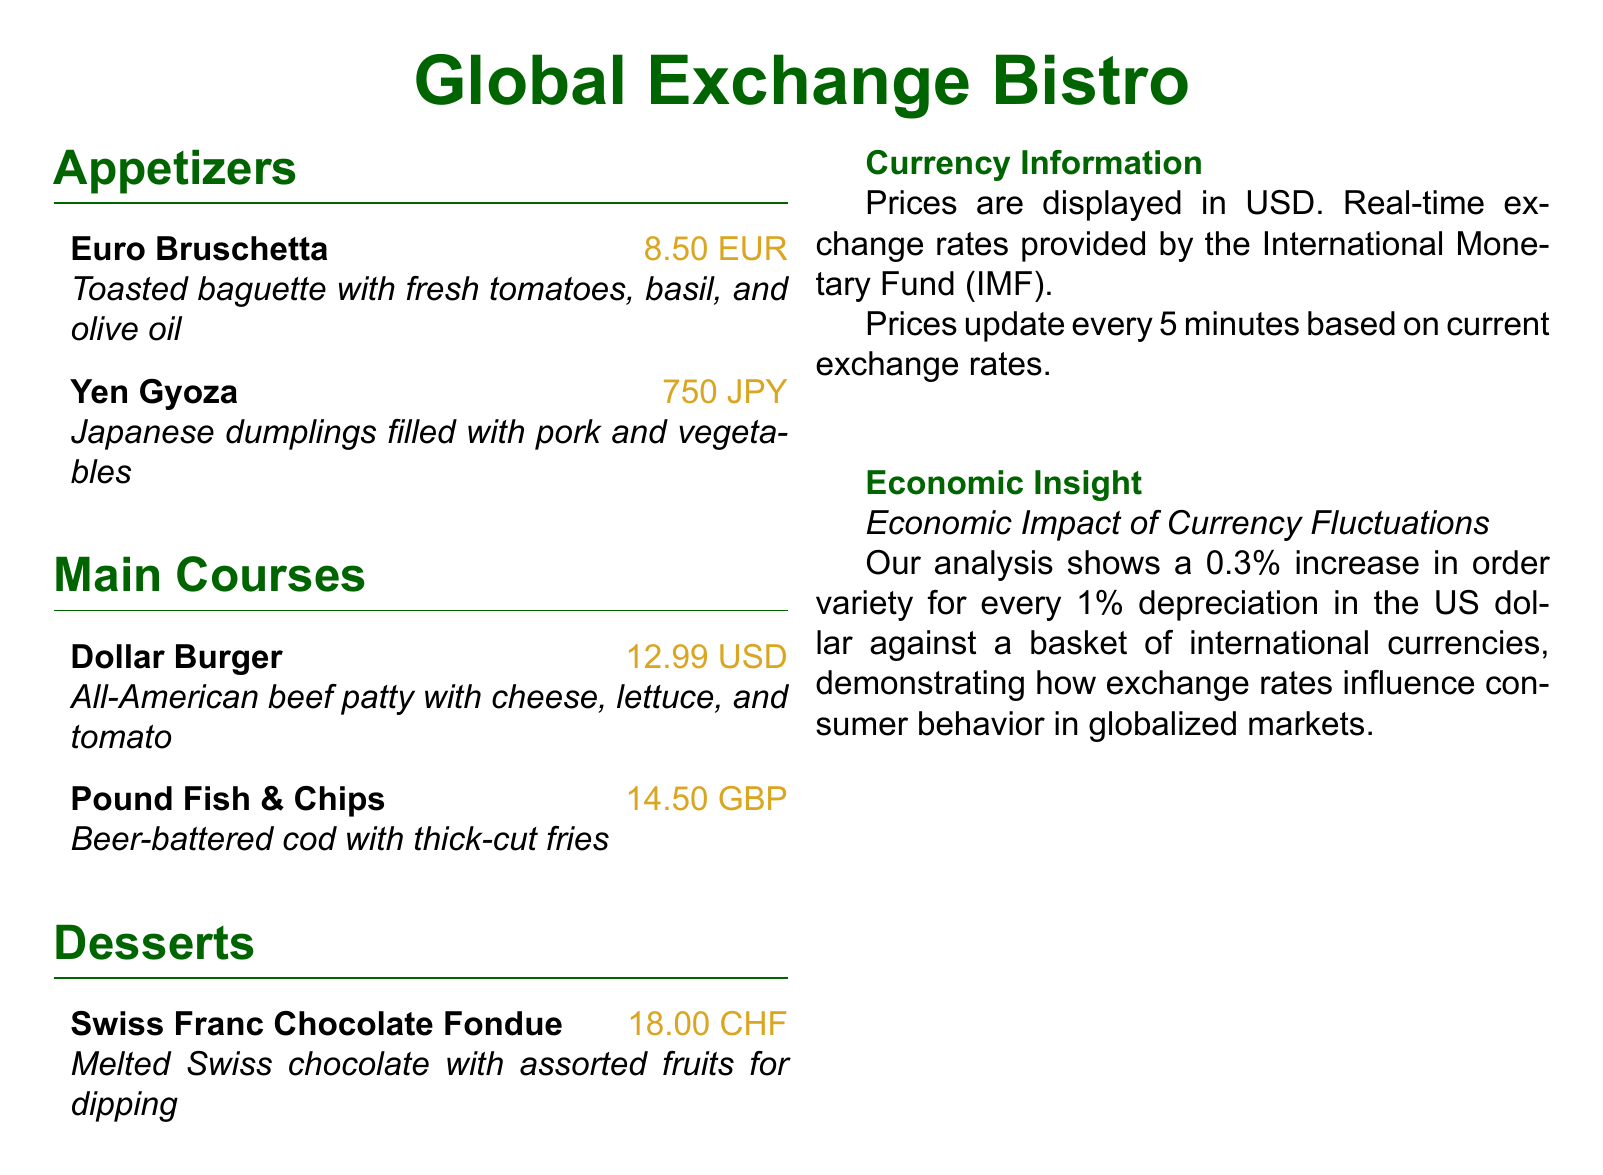What is the price of Euro Bruschetta? The price of Euro Bruschetta is listed in EUR within the document, which is 8.50.
Answer: 8.50 EUR How often do prices update? The document states that prices update every 5 minutes based on current exchange rates.
Answer: Every 5 minutes What is the currency displayed for the Dollar Burger? The document indicates that the Dollar Burger's price is shown in USD.
Answer: USD What type of dumplings is served as Yen Gyoza? The menu describes Yen Gyoza as Japanese dumplings filled with pork and vegetables.
Answer: Pork and vegetables What is the economic impact shown related to the US dollar? The document highlights a 0.3% increase in order variety for every 1% depreciation in the US dollar.
Answer: 0.3% What is the dessert item featured on the menu? The document lists Swiss Franc Chocolate Fondue as the dessert item.
Answer: Swiss Franc Chocolate Fondue What is the price of Pound Fish & Chips? The price for Pound Fish & Chips is provided in GBP as 14.50.
Answer: 14.50 GBP Which institution provides real-time exchange rates? The document specifies that real-time exchange rates are provided by the International Monetary Fund.
Answer: International Monetary Fund What is the color theme used in the menu title? The document showcases the color theme for the menu title as menugreen.
Answer: Menugreen 